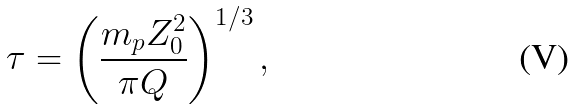<formula> <loc_0><loc_0><loc_500><loc_500>\tau = \left ( \frac { m _ { p } Z _ { 0 } ^ { 2 } } { \pi Q } \right ) ^ { 1 / 3 } ,</formula> 